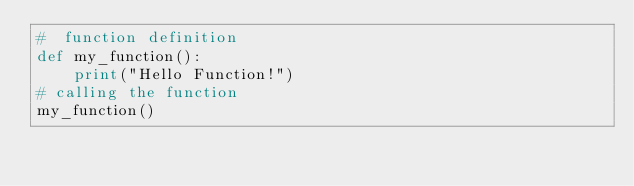Convert code to text. <code><loc_0><loc_0><loc_500><loc_500><_Python_>#  function definition
def my_function():
    print("Hello Function!")
# calling the function
my_function()    






</code> 